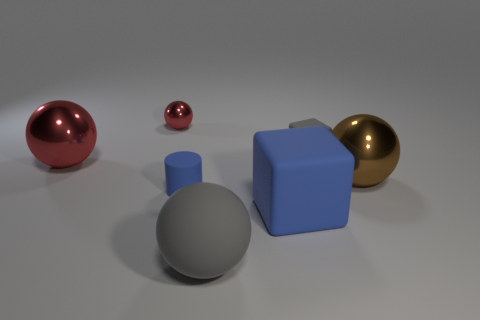How many cylinders are tiny metallic things or blue rubber objects?
Keep it short and to the point. 1. The rubber ball that is the same size as the brown metallic ball is what color?
Your answer should be very brief. Gray. What number of big things are both behind the brown metallic thing and right of the tiny red metallic thing?
Provide a succinct answer. 0. What material is the tiny red thing?
Offer a terse response. Metal. What number of objects are either tiny red spheres or large metal spheres?
Give a very brief answer. 3. There is a gray matte thing that is on the right side of the big gray rubber object; is it the same size as the gray object in front of the large blue rubber block?
Your answer should be compact. No. How many other things are there of the same size as the brown ball?
Keep it short and to the point. 3. How many objects are blocks on the right side of the blue matte cube or gray rubber things in front of the gray matte cube?
Ensure brevity in your answer.  2. Is the brown ball made of the same material as the blue thing in front of the cylinder?
Make the answer very short. No. What number of other objects are there of the same shape as the big blue object?
Make the answer very short. 1. 